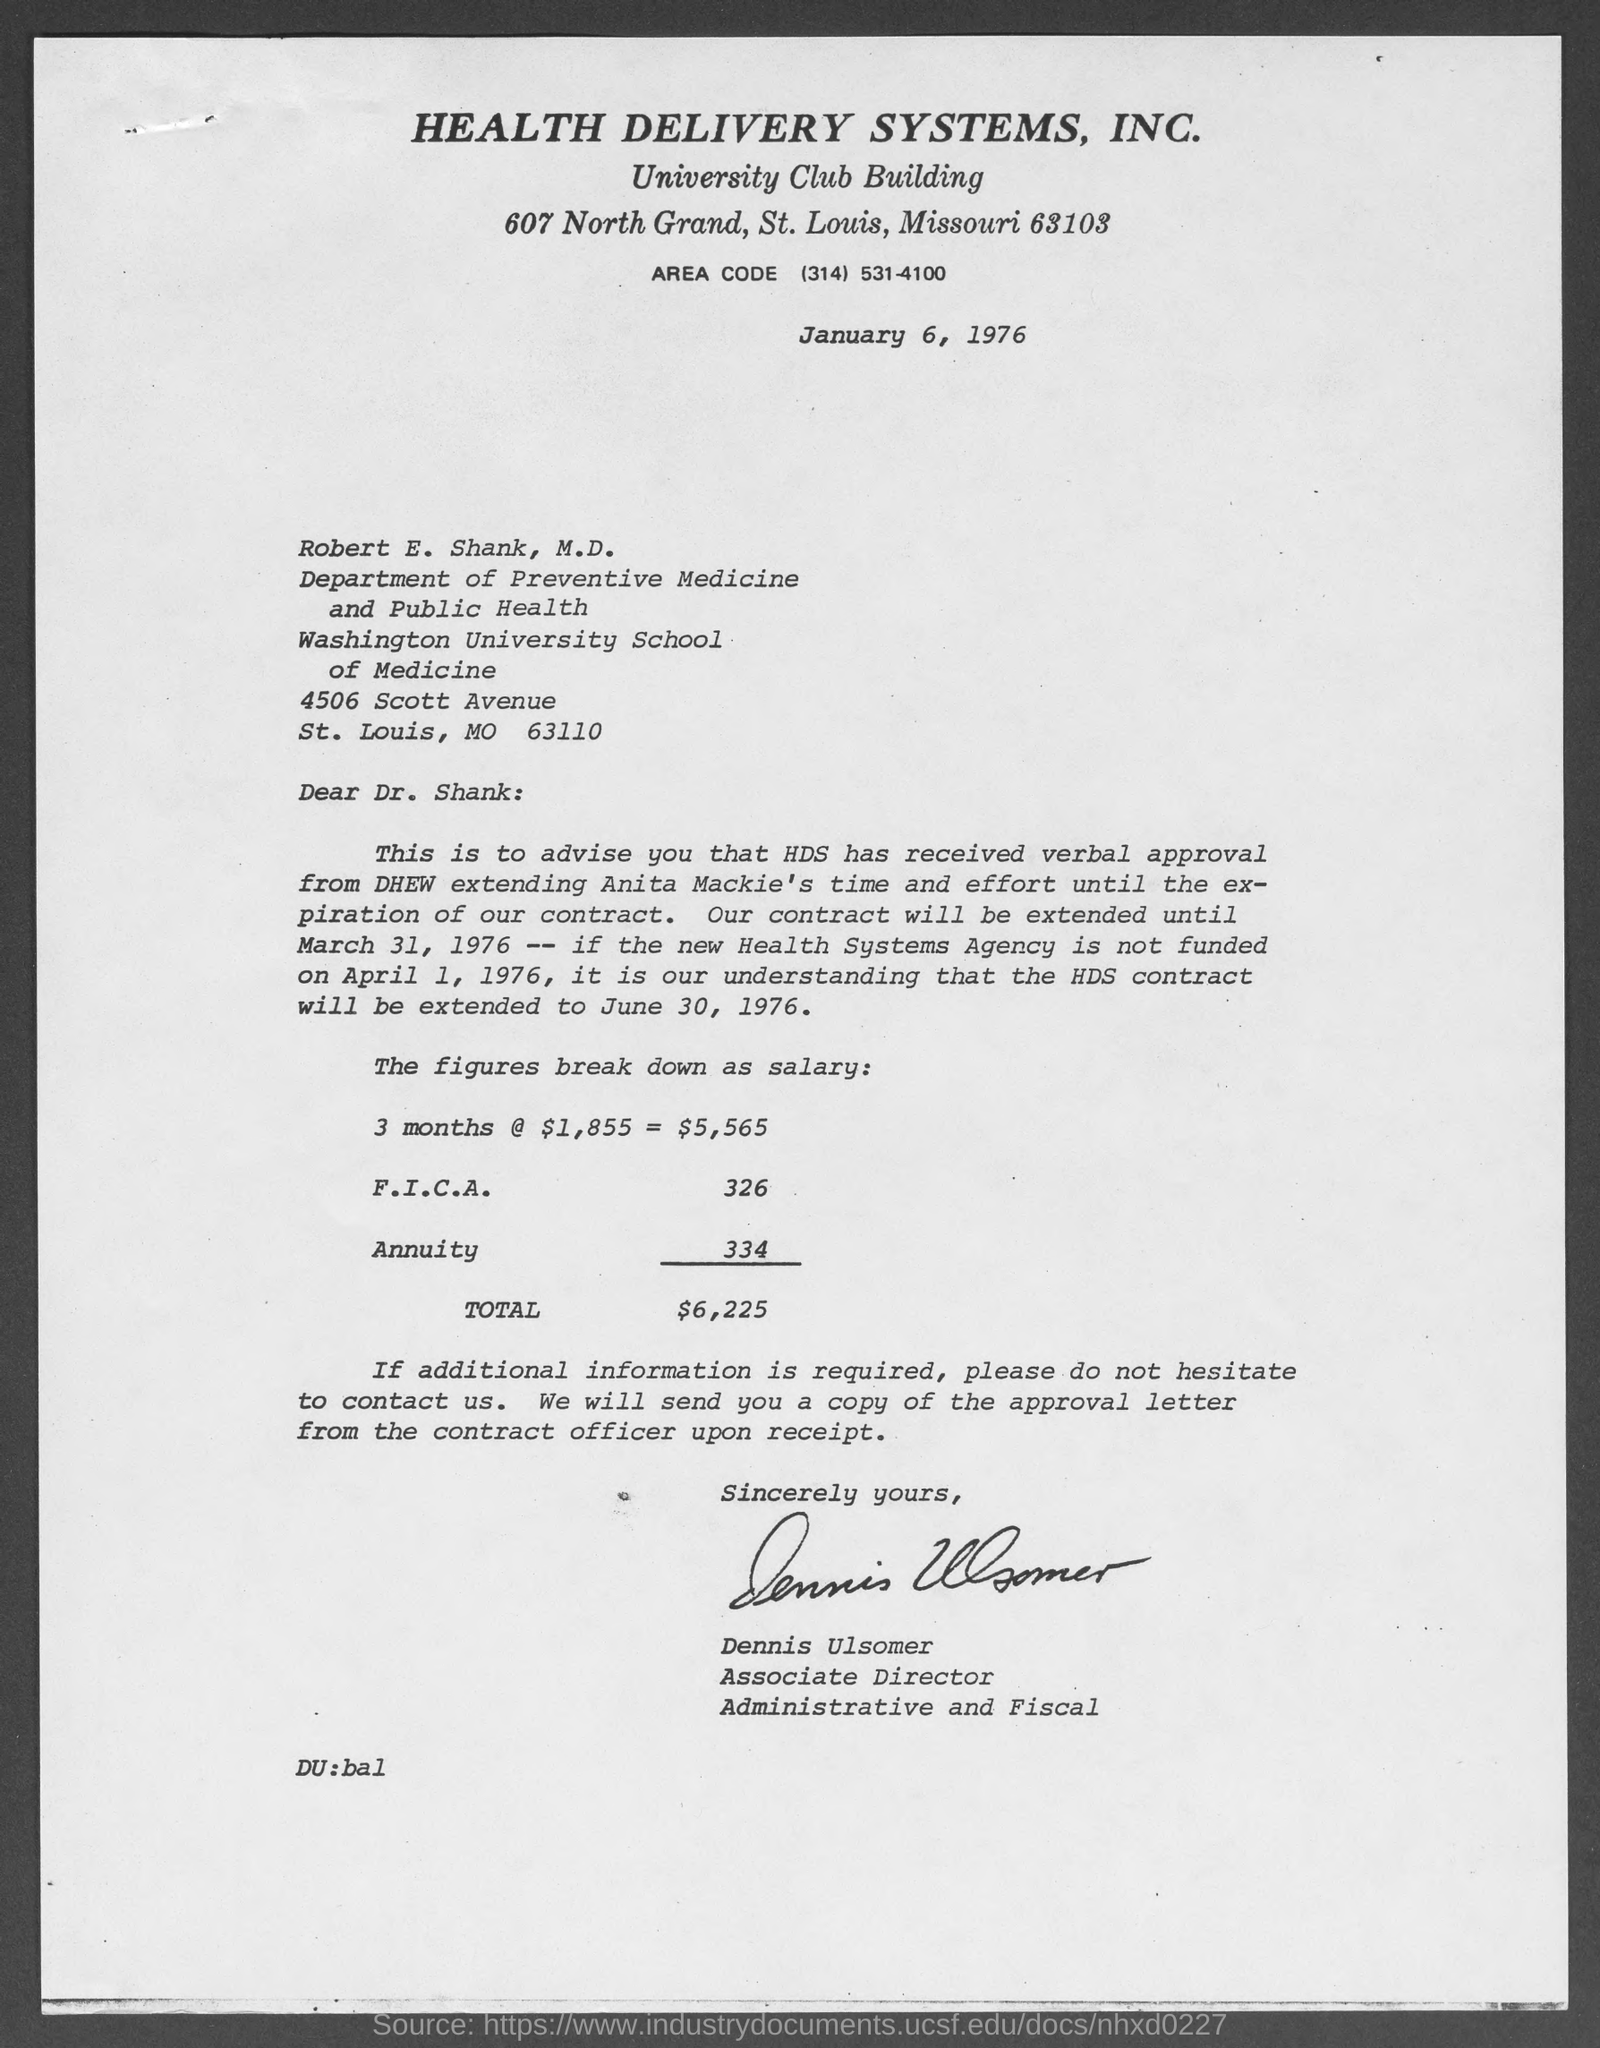Point out several critical features in this image. Dennis Ulsomer is the Associate Director. The annuity amount is 334. The date mentioned at the top of the document is January 6, 1976. The area code is the first three digits of a phone number and is used to identify the geographical region or service provider associated with that number. The area code for the phone number (314) 531-4100 is 314. 